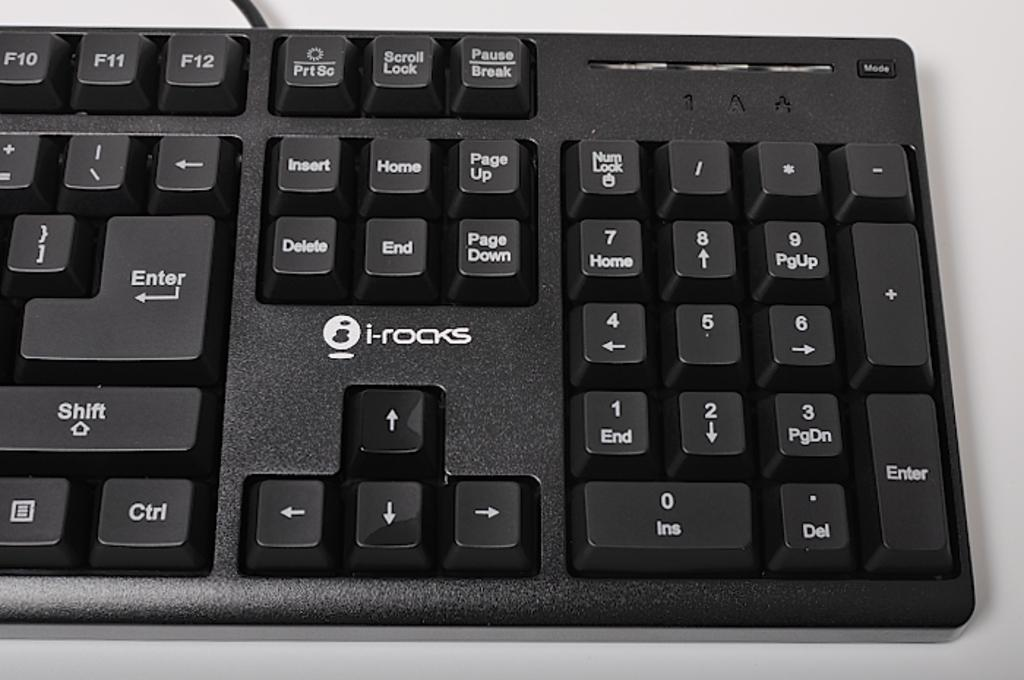<image>
Share a concise interpretation of the image provided. An i-rocks keyboard with keys like Insert and Home displayed. 